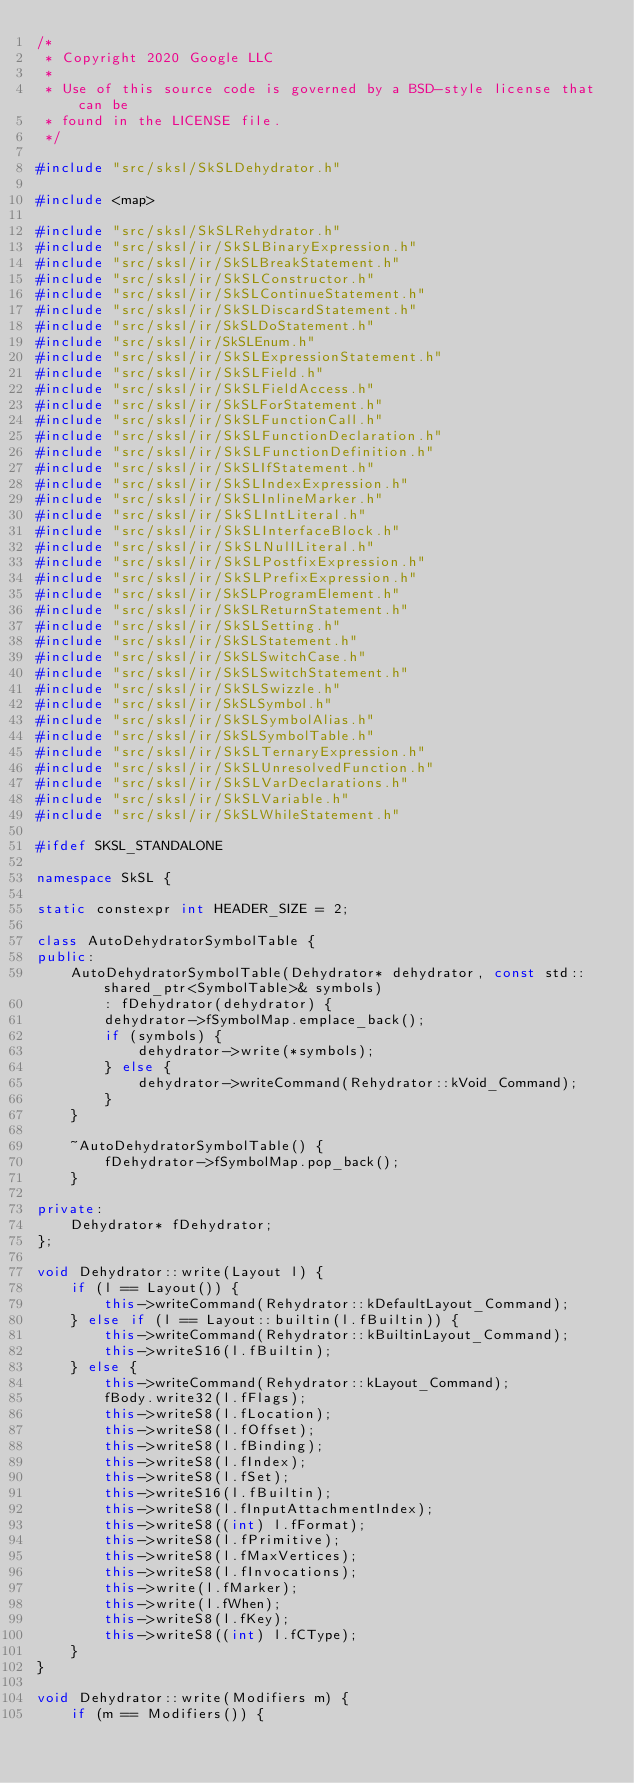Convert code to text. <code><loc_0><loc_0><loc_500><loc_500><_C++_>/*
 * Copyright 2020 Google LLC
 *
 * Use of this source code is governed by a BSD-style license that can be
 * found in the LICENSE file.
 */

#include "src/sksl/SkSLDehydrator.h"

#include <map>

#include "src/sksl/SkSLRehydrator.h"
#include "src/sksl/ir/SkSLBinaryExpression.h"
#include "src/sksl/ir/SkSLBreakStatement.h"
#include "src/sksl/ir/SkSLConstructor.h"
#include "src/sksl/ir/SkSLContinueStatement.h"
#include "src/sksl/ir/SkSLDiscardStatement.h"
#include "src/sksl/ir/SkSLDoStatement.h"
#include "src/sksl/ir/SkSLEnum.h"
#include "src/sksl/ir/SkSLExpressionStatement.h"
#include "src/sksl/ir/SkSLField.h"
#include "src/sksl/ir/SkSLFieldAccess.h"
#include "src/sksl/ir/SkSLForStatement.h"
#include "src/sksl/ir/SkSLFunctionCall.h"
#include "src/sksl/ir/SkSLFunctionDeclaration.h"
#include "src/sksl/ir/SkSLFunctionDefinition.h"
#include "src/sksl/ir/SkSLIfStatement.h"
#include "src/sksl/ir/SkSLIndexExpression.h"
#include "src/sksl/ir/SkSLInlineMarker.h"
#include "src/sksl/ir/SkSLIntLiteral.h"
#include "src/sksl/ir/SkSLInterfaceBlock.h"
#include "src/sksl/ir/SkSLNullLiteral.h"
#include "src/sksl/ir/SkSLPostfixExpression.h"
#include "src/sksl/ir/SkSLPrefixExpression.h"
#include "src/sksl/ir/SkSLProgramElement.h"
#include "src/sksl/ir/SkSLReturnStatement.h"
#include "src/sksl/ir/SkSLSetting.h"
#include "src/sksl/ir/SkSLStatement.h"
#include "src/sksl/ir/SkSLSwitchCase.h"
#include "src/sksl/ir/SkSLSwitchStatement.h"
#include "src/sksl/ir/SkSLSwizzle.h"
#include "src/sksl/ir/SkSLSymbol.h"
#include "src/sksl/ir/SkSLSymbolAlias.h"
#include "src/sksl/ir/SkSLSymbolTable.h"
#include "src/sksl/ir/SkSLTernaryExpression.h"
#include "src/sksl/ir/SkSLUnresolvedFunction.h"
#include "src/sksl/ir/SkSLVarDeclarations.h"
#include "src/sksl/ir/SkSLVariable.h"
#include "src/sksl/ir/SkSLWhileStatement.h"

#ifdef SKSL_STANDALONE

namespace SkSL {

static constexpr int HEADER_SIZE = 2;

class AutoDehydratorSymbolTable {
public:
    AutoDehydratorSymbolTable(Dehydrator* dehydrator, const std::shared_ptr<SymbolTable>& symbols)
        : fDehydrator(dehydrator) {
        dehydrator->fSymbolMap.emplace_back();
        if (symbols) {
            dehydrator->write(*symbols);
        } else {
            dehydrator->writeCommand(Rehydrator::kVoid_Command);
        }
    }

    ~AutoDehydratorSymbolTable() {
        fDehydrator->fSymbolMap.pop_back();
    }

private:
    Dehydrator* fDehydrator;
};

void Dehydrator::write(Layout l) {
    if (l == Layout()) {
        this->writeCommand(Rehydrator::kDefaultLayout_Command);
    } else if (l == Layout::builtin(l.fBuiltin)) {
        this->writeCommand(Rehydrator::kBuiltinLayout_Command);
        this->writeS16(l.fBuiltin);
    } else {
        this->writeCommand(Rehydrator::kLayout_Command);
        fBody.write32(l.fFlags);
        this->writeS8(l.fLocation);
        this->writeS8(l.fOffset);
        this->writeS8(l.fBinding);
        this->writeS8(l.fIndex);
        this->writeS8(l.fSet);
        this->writeS16(l.fBuiltin);
        this->writeS8(l.fInputAttachmentIndex);
        this->writeS8((int) l.fFormat);
        this->writeS8(l.fPrimitive);
        this->writeS8(l.fMaxVertices);
        this->writeS8(l.fInvocations);
        this->write(l.fMarker);
        this->write(l.fWhen);
        this->writeS8(l.fKey);
        this->writeS8((int) l.fCType);
    }
}

void Dehydrator::write(Modifiers m) {
    if (m == Modifiers()) {</code> 